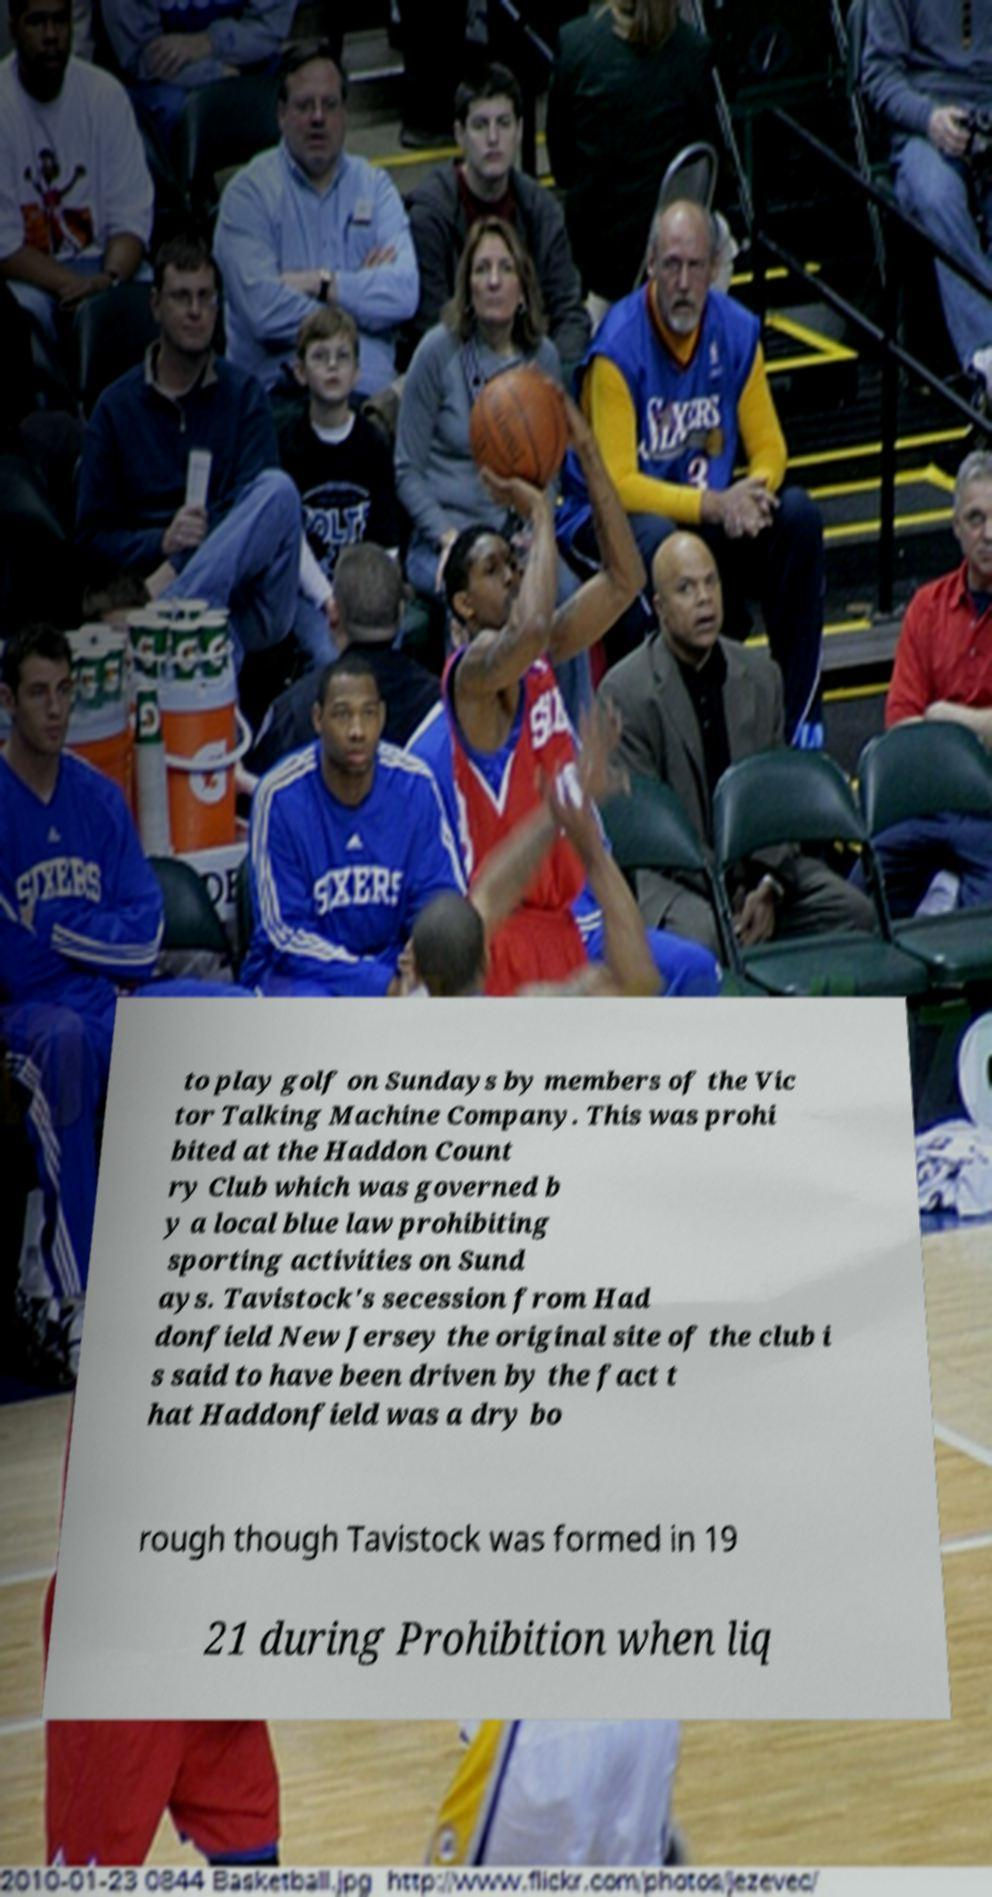There's text embedded in this image that I need extracted. Can you transcribe it verbatim? to play golf on Sundays by members of the Vic tor Talking Machine Company. This was prohi bited at the Haddon Count ry Club which was governed b y a local blue law prohibiting sporting activities on Sund ays. Tavistock's secession from Had donfield New Jersey the original site of the club i s said to have been driven by the fact t hat Haddonfield was a dry bo rough though Tavistock was formed in 19 21 during Prohibition when liq 